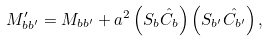<formula> <loc_0><loc_0><loc_500><loc_500>M ^ { \prime } _ { b b ^ { \prime } } = M _ { b b ^ { \prime } } + a ^ { 2 } \left ( S _ { b } \hat { C _ { b } } \right ) \left ( S _ { b ^ { \prime } } \hat { C _ { b ^ { \prime } } } \right ) ,</formula> 